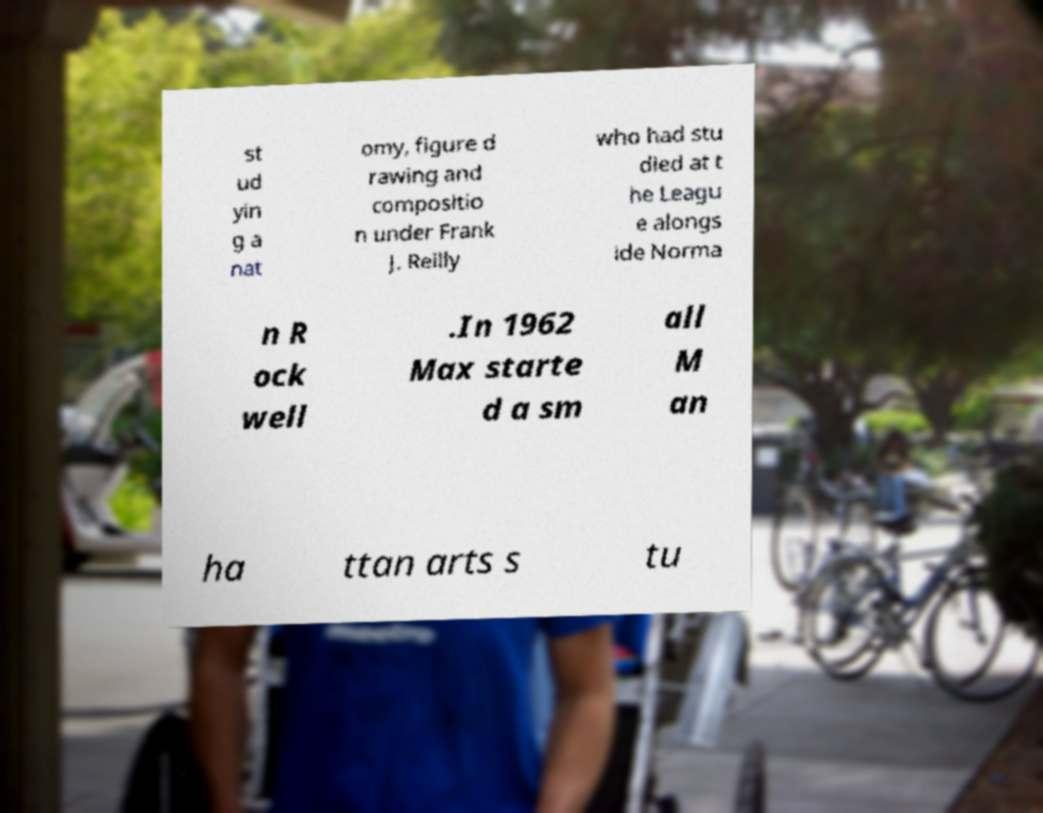Can you read and provide the text displayed in the image?This photo seems to have some interesting text. Can you extract and type it out for me? st ud yin g a nat omy, figure d rawing and compositio n under Frank J. Reilly who had stu died at t he Leagu e alongs ide Norma n R ock well .In 1962 Max starte d a sm all M an ha ttan arts s tu 